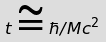Convert formula to latex. <formula><loc_0><loc_0><loc_500><loc_500>t \cong \hbar { / } M c ^ { 2 }</formula> 